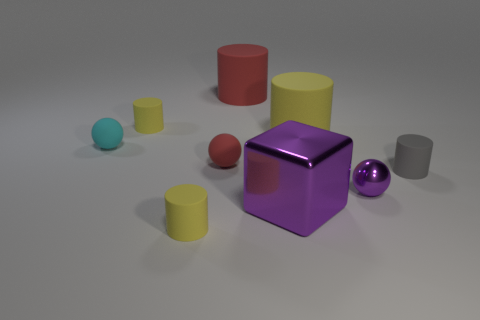What shape is the small object that is the same color as the big block?
Ensure brevity in your answer.  Sphere. There is a rubber object that is both to the right of the big red thing and behind the red rubber ball; what size is it?
Ensure brevity in your answer.  Large. There is a red matte thing right of the red rubber ball; is its size the same as the tiny red thing?
Your response must be concise. No. There is a purple metallic thing that is in front of the small shiny sphere; how many cylinders are in front of it?
Make the answer very short. 1. Is the shape of the small gray matte object the same as the large yellow object?
Provide a succinct answer. Yes. Is there any other thing that is the same color as the large block?
Your answer should be compact. Yes. Do the tiny gray matte thing and the large red object to the left of the metallic cube have the same shape?
Provide a short and direct response. Yes. There is a tiny object that is left of the tiny yellow matte object that is behind the small rubber thing to the right of the large red matte object; what color is it?
Offer a terse response. Cyan. There is a yellow thing in front of the purple cube; is its shape the same as the large purple metallic thing?
Offer a terse response. No. What material is the large yellow object?
Provide a succinct answer. Rubber. 